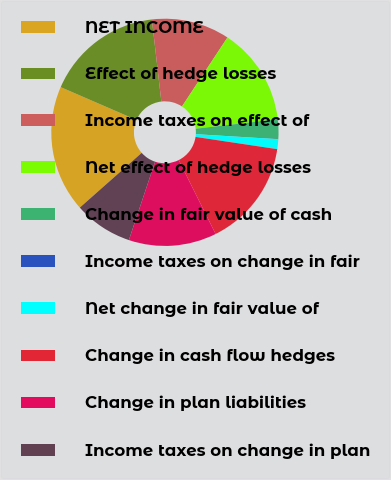Convert chart. <chart><loc_0><loc_0><loc_500><loc_500><pie_chart><fcel>NET INCOME<fcel>Effect of hedge losses<fcel>Income taxes on effect of<fcel>Net effect of hedge losses<fcel>Change in fair value of cash<fcel>Income taxes on change in fair<fcel>Net change in fair value of<fcel>Change in cash flow hedges<fcel>Change in plan liabilities<fcel>Income taxes on change in plan<nl><fcel>18.04%<fcel>16.66%<fcel>11.11%<fcel>13.88%<fcel>2.79%<fcel>0.02%<fcel>1.4%<fcel>15.27%<fcel>12.5%<fcel>8.34%<nl></chart> 